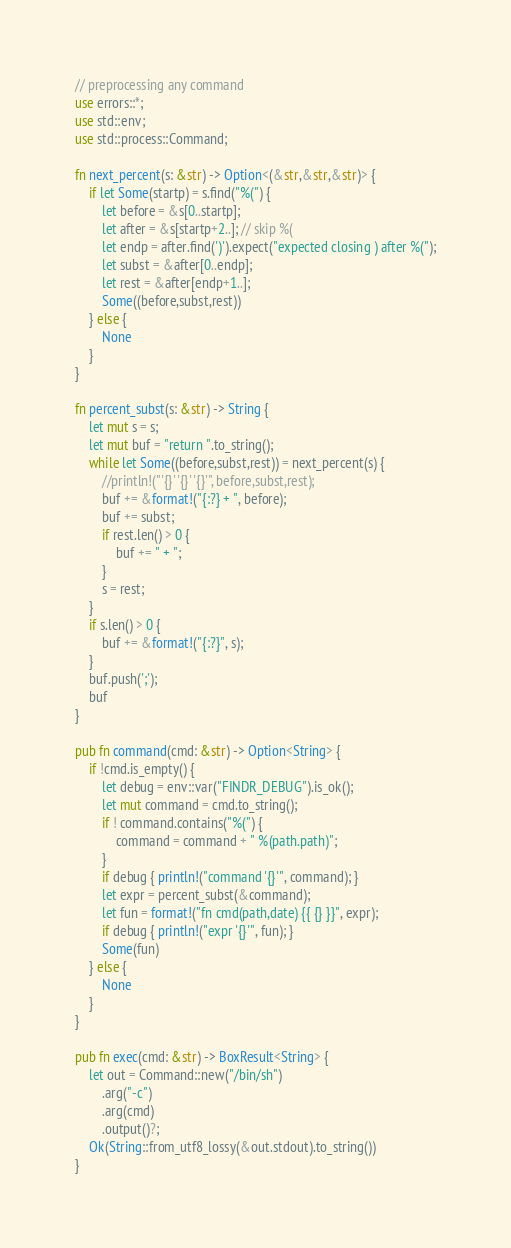<code> <loc_0><loc_0><loc_500><loc_500><_Rust_>// preprocessing any command
use errors::*;
use std::env;
use std::process::Command;

fn next_percent(s: &str) -> Option<(&str,&str,&str)> {
    if let Some(startp) = s.find("%(") {
        let before = &s[0..startp];
        let after = &s[startp+2..]; // skip %(
        let endp = after.find(')').expect("expected closing ) after %(");
        let subst = &after[0..endp];
        let rest = &after[endp+1..];
        Some((before,subst,rest))
    } else {
        None
    }
}

fn percent_subst(s: &str) -> String {
    let mut s = s;
    let mut buf = "return ".to_string();
    while let Some((before,subst,rest)) = next_percent(s) {
        //println!("'{}' '{}' '{}'", before,subst,rest);
        buf += &format!("{:?} + ", before);
        buf += subst;
        if rest.len() > 0 {
            buf += " + ";
        }
        s = rest;
    }
    if s.len() > 0 {
        buf += &format!("{:?}", s);
    }
    buf.push(';');
    buf
}

pub fn command(cmd: &str) -> Option<String> {
    if !cmd.is_empty() {
        let debug = env::var("FINDR_DEBUG").is_ok();
        let mut command = cmd.to_string();
        if ! command.contains("%(") {
            command = command + " %(path.path)";
        }
        if debug { println!("command '{}'", command); }
        let expr = percent_subst(&command);
        let fun = format!("fn cmd(path,date) {{ {} }}", expr);
        if debug { println!("expr '{}'", fun); }
        Some(fun)
    } else {
        None
    }
}

pub fn exec(cmd: &str) -> BoxResult<String> {
    let out = Command::new("/bin/sh")
        .arg("-c")
        .arg(cmd)
        .output()?;
    Ok(String::from_utf8_lossy(&out.stdout).to_string())
}
</code> 